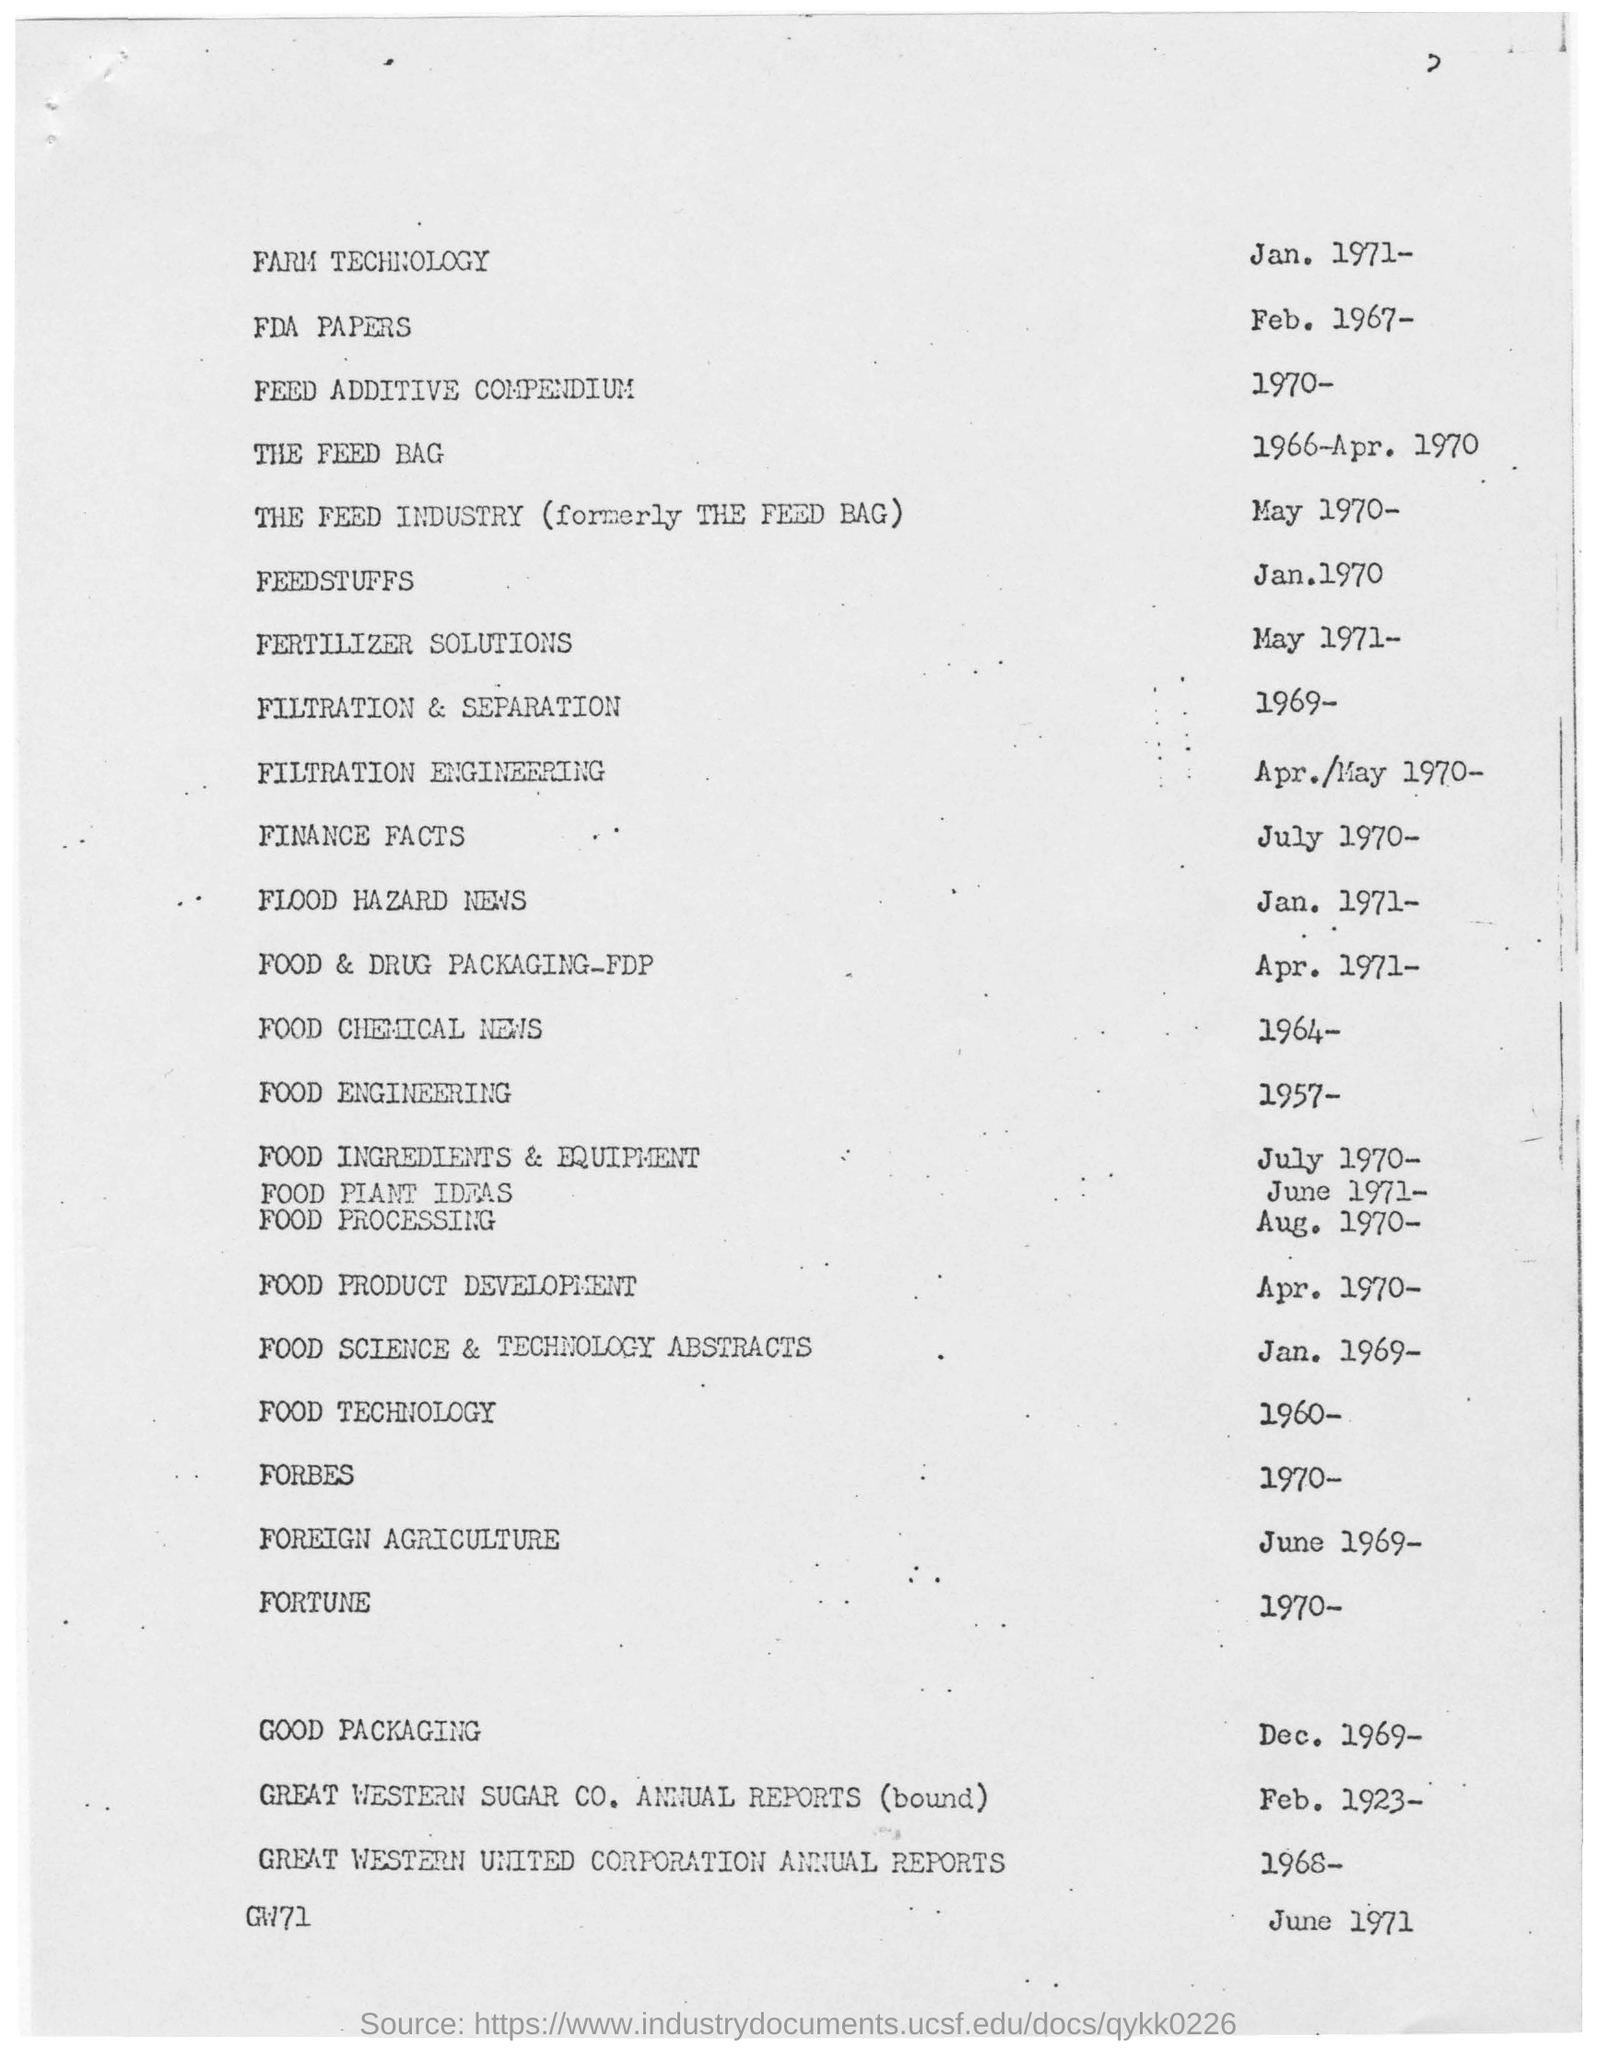What is the year mentioned for farm technology ?
Your answer should be compact. 1971-. 